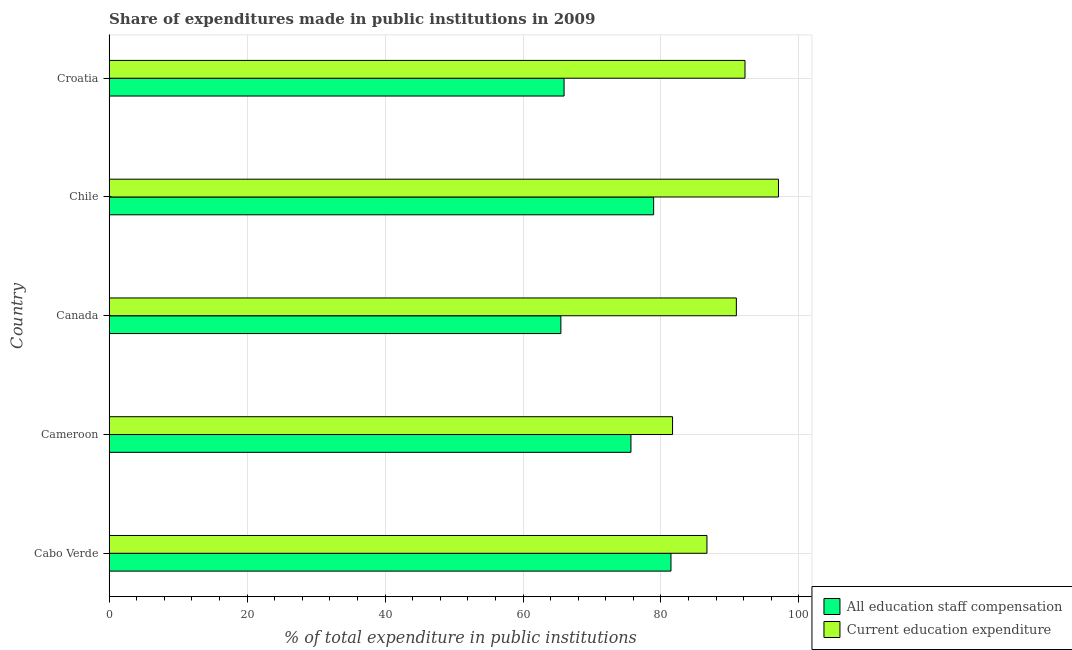How many bars are there on the 4th tick from the top?
Keep it short and to the point. 2. What is the label of the 1st group of bars from the top?
Ensure brevity in your answer.  Croatia. In how many cases, is the number of bars for a given country not equal to the number of legend labels?
Your response must be concise. 0. What is the expenditure in staff compensation in Chile?
Keep it short and to the point. 78.94. Across all countries, what is the maximum expenditure in education?
Your answer should be very brief. 97.03. Across all countries, what is the minimum expenditure in staff compensation?
Make the answer very short. 65.49. In which country was the expenditure in staff compensation maximum?
Your answer should be very brief. Cabo Verde. What is the total expenditure in staff compensation in the graph?
Offer a terse response. 367.48. What is the difference between the expenditure in staff compensation in Cameroon and that in Canada?
Ensure brevity in your answer.  10.16. What is the difference between the expenditure in education in Croatia and the expenditure in staff compensation in Chile?
Keep it short and to the point. 13.24. What is the average expenditure in education per country?
Keep it short and to the point. 89.69. What is the difference between the expenditure in staff compensation and expenditure in education in Cabo Verde?
Give a very brief answer. -5.22. In how many countries, is the expenditure in education greater than 76 %?
Offer a very short reply. 5. What is the ratio of the expenditure in staff compensation in Cabo Verde to that in Canada?
Provide a short and direct response. 1.24. Is the difference between the expenditure in education in Cabo Verde and Croatia greater than the difference between the expenditure in staff compensation in Cabo Verde and Croatia?
Provide a succinct answer. No. What is the difference between the highest and the second highest expenditure in staff compensation?
Your response must be concise. 2.51. What is the difference between the highest and the lowest expenditure in education?
Keep it short and to the point. 15.35. In how many countries, is the expenditure in education greater than the average expenditure in education taken over all countries?
Offer a very short reply. 3. Is the sum of the expenditure in staff compensation in Cameroon and Croatia greater than the maximum expenditure in education across all countries?
Provide a short and direct response. Yes. What does the 2nd bar from the top in Canada represents?
Provide a short and direct response. All education staff compensation. What does the 2nd bar from the bottom in Cameroon represents?
Your response must be concise. Current education expenditure. How many bars are there?
Give a very brief answer. 10. Are all the bars in the graph horizontal?
Offer a terse response. Yes. How many countries are there in the graph?
Give a very brief answer. 5. What is the difference between two consecutive major ticks on the X-axis?
Ensure brevity in your answer.  20. Does the graph contain any zero values?
Your answer should be compact. No. Where does the legend appear in the graph?
Provide a short and direct response. Bottom right. What is the title of the graph?
Provide a succinct answer. Share of expenditures made in public institutions in 2009. Does "Taxes on exports" appear as one of the legend labels in the graph?
Ensure brevity in your answer.  No. What is the label or title of the X-axis?
Provide a succinct answer. % of total expenditure in public institutions. What is the % of total expenditure in public institutions of All education staff compensation in Cabo Verde?
Your answer should be very brief. 81.45. What is the % of total expenditure in public institutions in Current education expenditure in Cabo Verde?
Provide a short and direct response. 86.66. What is the % of total expenditure in public institutions of All education staff compensation in Cameroon?
Ensure brevity in your answer.  75.65. What is the % of total expenditure in public institutions of Current education expenditure in Cameroon?
Provide a short and direct response. 81.68. What is the % of total expenditure in public institutions of All education staff compensation in Canada?
Provide a succinct answer. 65.49. What is the % of total expenditure in public institutions in Current education expenditure in Canada?
Give a very brief answer. 90.93. What is the % of total expenditure in public institutions of All education staff compensation in Chile?
Offer a very short reply. 78.94. What is the % of total expenditure in public institutions in Current education expenditure in Chile?
Your response must be concise. 97.03. What is the % of total expenditure in public institutions of All education staff compensation in Croatia?
Provide a short and direct response. 65.95. What is the % of total expenditure in public institutions of Current education expenditure in Croatia?
Provide a short and direct response. 92.18. Across all countries, what is the maximum % of total expenditure in public institutions of All education staff compensation?
Your answer should be compact. 81.45. Across all countries, what is the maximum % of total expenditure in public institutions in Current education expenditure?
Ensure brevity in your answer.  97.03. Across all countries, what is the minimum % of total expenditure in public institutions in All education staff compensation?
Your answer should be compact. 65.49. Across all countries, what is the minimum % of total expenditure in public institutions of Current education expenditure?
Provide a succinct answer. 81.68. What is the total % of total expenditure in public institutions in All education staff compensation in the graph?
Your answer should be very brief. 367.48. What is the total % of total expenditure in public institutions of Current education expenditure in the graph?
Give a very brief answer. 448.48. What is the difference between the % of total expenditure in public institutions of All education staff compensation in Cabo Verde and that in Cameroon?
Your answer should be compact. 5.8. What is the difference between the % of total expenditure in public institutions in Current education expenditure in Cabo Verde and that in Cameroon?
Offer a very short reply. 4.99. What is the difference between the % of total expenditure in public institutions of All education staff compensation in Cabo Verde and that in Canada?
Offer a very short reply. 15.96. What is the difference between the % of total expenditure in public institutions of Current education expenditure in Cabo Verde and that in Canada?
Ensure brevity in your answer.  -4.26. What is the difference between the % of total expenditure in public institutions of All education staff compensation in Cabo Verde and that in Chile?
Your response must be concise. 2.51. What is the difference between the % of total expenditure in public institutions in Current education expenditure in Cabo Verde and that in Chile?
Your response must be concise. -10.37. What is the difference between the % of total expenditure in public institutions in All education staff compensation in Cabo Verde and that in Croatia?
Provide a succinct answer. 15.49. What is the difference between the % of total expenditure in public institutions of Current education expenditure in Cabo Verde and that in Croatia?
Give a very brief answer. -5.51. What is the difference between the % of total expenditure in public institutions in All education staff compensation in Cameroon and that in Canada?
Your answer should be compact. 10.16. What is the difference between the % of total expenditure in public institutions in Current education expenditure in Cameroon and that in Canada?
Your answer should be compact. -9.25. What is the difference between the % of total expenditure in public institutions in All education staff compensation in Cameroon and that in Chile?
Provide a short and direct response. -3.29. What is the difference between the % of total expenditure in public institutions of Current education expenditure in Cameroon and that in Chile?
Keep it short and to the point. -15.35. What is the difference between the % of total expenditure in public institutions in All education staff compensation in Cameroon and that in Croatia?
Your response must be concise. 9.69. What is the difference between the % of total expenditure in public institutions of Current education expenditure in Cameroon and that in Croatia?
Your response must be concise. -10.5. What is the difference between the % of total expenditure in public institutions in All education staff compensation in Canada and that in Chile?
Your response must be concise. -13.45. What is the difference between the % of total expenditure in public institutions of Current education expenditure in Canada and that in Chile?
Offer a terse response. -6.1. What is the difference between the % of total expenditure in public institutions in All education staff compensation in Canada and that in Croatia?
Make the answer very short. -0.47. What is the difference between the % of total expenditure in public institutions in Current education expenditure in Canada and that in Croatia?
Your answer should be compact. -1.25. What is the difference between the % of total expenditure in public institutions of All education staff compensation in Chile and that in Croatia?
Ensure brevity in your answer.  12.98. What is the difference between the % of total expenditure in public institutions in Current education expenditure in Chile and that in Croatia?
Your response must be concise. 4.85. What is the difference between the % of total expenditure in public institutions of All education staff compensation in Cabo Verde and the % of total expenditure in public institutions of Current education expenditure in Cameroon?
Ensure brevity in your answer.  -0.23. What is the difference between the % of total expenditure in public institutions in All education staff compensation in Cabo Verde and the % of total expenditure in public institutions in Current education expenditure in Canada?
Make the answer very short. -9.48. What is the difference between the % of total expenditure in public institutions in All education staff compensation in Cabo Verde and the % of total expenditure in public institutions in Current education expenditure in Chile?
Your answer should be compact. -15.58. What is the difference between the % of total expenditure in public institutions in All education staff compensation in Cabo Verde and the % of total expenditure in public institutions in Current education expenditure in Croatia?
Provide a short and direct response. -10.73. What is the difference between the % of total expenditure in public institutions in All education staff compensation in Cameroon and the % of total expenditure in public institutions in Current education expenditure in Canada?
Offer a terse response. -15.28. What is the difference between the % of total expenditure in public institutions in All education staff compensation in Cameroon and the % of total expenditure in public institutions in Current education expenditure in Chile?
Your answer should be very brief. -21.38. What is the difference between the % of total expenditure in public institutions in All education staff compensation in Cameroon and the % of total expenditure in public institutions in Current education expenditure in Croatia?
Your answer should be very brief. -16.53. What is the difference between the % of total expenditure in public institutions of All education staff compensation in Canada and the % of total expenditure in public institutions of Current education expenditure in Chile?
Offer a terse response. -31.54. What is the difference between the % of total expenditure in public institutions of All education staff compensation in Canada and the % of total expenditure in public institutions of Current education expenditure in Croatia?
Provide a short and direct response. -26.69. What is the difference between the % of total expenditure in public institutions of All education staff compensation in Chile and the % of total expenditure in public institutions of Current education expenditure in Croatia?
Keep it short and to the point. -13.24. What is the average % of total expenditure in public institutions in All education staff compensation per country?
Make the answer very short. 73.5. What is the average % of total expenditure in public institutions of Current education expenditure per country?
Your answer should be compact. 89.7. What is the difference between the % of total expenditure in public institutions in All education staff compensation and % of total expenditure in public institutions in Current education expenditure in Cabo Verde?
Offer a very short reply. -5.22. What is the difference between the % of total expenditure in public institutions of All education staff compensation and % of total expenditure in public institutions of Current education expenditure in Cameroon?
Ensure brevity in your answer.  -6.03. What is the difference between the % of total expenditure in public institutions of All education staff compensation and % of total expenditure in public institutions of Current education expenditure in Canada?
Make the answer very short. -25.44. What is the difference between the % of total expenditure in public institutions in All education staff compensation and % of total expenditure in public institutions in Current education expenditure in Chile?
Offer a terse response. -18.1. What is the difference between the % of total expenditure in public institutions in All education staff compensation and % of total expenditure in public institutions in Current education expenditure in Croatia?
Provide a short and direct response. -26.22. What is the ratio of the % of total expenditure in public institutions in All education staff compensation in Cabo Verde to that in Cameroon?
Ensure brevity in your answer.  1.08. What is the ratio of the % of total expenditure in public institutions of Current education expenditure in Cabo Verde to that in Cameroon?
Offer a terse response. 1.06. What is the ratio of the % of total expenditure in public institutions of All education staff compensation in Cabo Verde to that in Canada?
Your answer should be compact. 1.24. What is the ratio of the % of total expenditure in public institutions in Current education expenditure in Cabo Verde to that in Canada?
Offer a very short reply. 0.95. What is the ratio of the % of total expenditure in public institutions in All education staff compensation in Cabo Verde to that in Chile?
Provide a short and direct response. 1.03. What is the ratio of the % of total expenditure in public institutions of Current education expenditure in Cabo Verde to that in Chile?
Your response must be concise. 0.89. What is the ratio of the % of total expenditure in public institutions of All education staff compensation in Cabo Verde to that in Croatia?
Make the answer very short. 1.23. What is the ratio of the % of total expenditure in public institutions of Current education expenditure in Cabo Verde to that in Croatia?
Your answer should be compact. 0.94. What is the ratio of the % of total expenditure in public institutions of All education staff compensation in Cameroon to that in Canada?
Your answer should be very brief. 1.16. What is the ratio of the % of total expenditure in public institutions in Current education expenditure in Cameroon to that in Canada?
Make the answer very short. 0.9. What is the ratio of the % of total expenditure in public institutions in Current education expenditure in Cameroon to that in Chile?
Your answer should be compact. 0.84. What is the ratio of the % of total expenditure in public institutions in All education staff compensation in Cameroon to that in Croatia?
Offer a terse response. 1.15. What is the ratio of the % of total expenditure in public institutions in Current education expenditure in Cameroon to that in Croatia?
Your answer should be very brief. 0.89. What is the ratio of the % of total expenditure in public institutions of All education staff compensation in Canada to that in Chile?
Offer a very short reply. 0.83. What is the ratio of the % of total expenditure in public institutions of Current education expenditure in Canada to that in Chile?
Keep it short and to the point. 0.94. What is the ratio of the % of total expenditure in public institutions of Current education expenditure in Canada to that in Croatia?
Ensure brevity in your answer.  0.99. What is the ratio of the % of total expenditure in public institutions of All education staff compensation in Chile to that in Croatia?
Keep it short and to the point. 1.2. What is the ratio of the % of total expenditure in public institutions in Current education expenditure in Chile to that in Croatia?
Give a very brief answer. 1.05. What is the difference between the highest and the second highest % of total expenditure in public institutions in All education staff compensation?
Ensure brevity in your answer.  2.51. What is the difference between the highest and the second highest % of total expenditure in public institutions in Current education expenditure?
Ensure brevity in your answer.  4.85. What is the difference between the highest and the lowest % of total expenditure in public institutions in All education staff compensation?
Provide a succinct answer. 15.96. What is the difference between the highest and the lowest % of total expenditure in public institutions in Current education expenditure?
Provide a succinct answer. 15.35. 